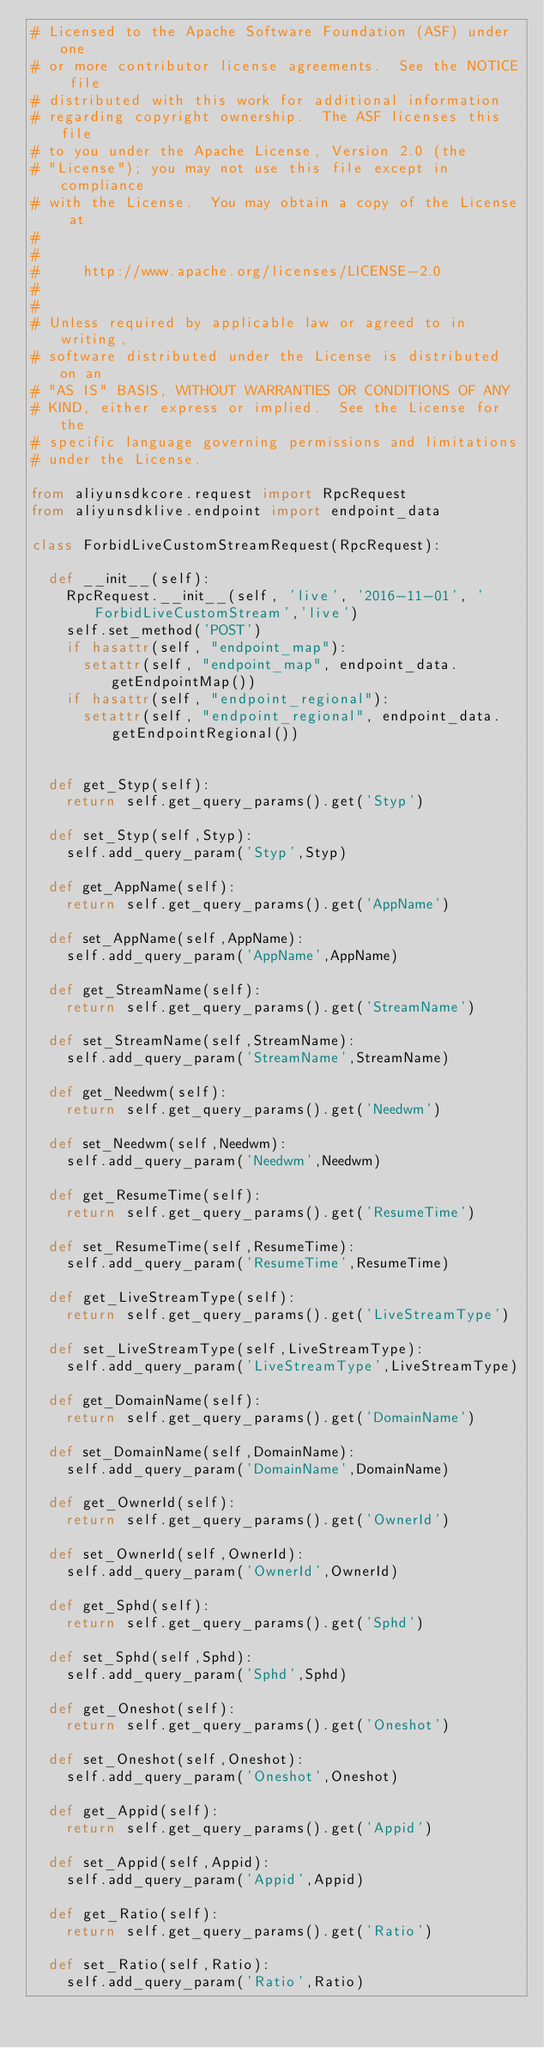<code> <loc_0><loc_0><loc_500><loc_500><_Python_># Licensed to the Apache Software Foundation (ASF) under one
# or more contributor license agreements.  See the NOTICE file
# distributed with this work for additional information
# regarding copyright ownership.  The ASF licenses this file
# to you under the Apache License, Version 2.0 (the
# "License"); you may not use this file except in compliance
# with the License.  You may obtain a copy of the License at
#
#
#     http://www.apache.org/licenses/LICENSE-2.0
#
#
# Unless required by applicable law or agreed to in writing,
# software distributed under the License is distributed on an
# "AS IS" BASIS, WITHOUT WARRANTIES OR CONDITIONS OF ANY
# KIND, either express or implied.  See the License for the
# specific language governing permissions and limitations
# under the License.

from aliyunsdkcore.request import RpcRequest
from aliyunsdklive.endpoint import endpoint_data

class ForbidLiveCustomStreamRequest(RpcRequest):

	def __init__(self):
		RpcRequest.__init__(self, 'live', '2016-11-01', 'ForbidLiveCustomStream','live')
		self.set_method('POST')
		if hasattr(self, "endpoint_map"):
			setattr(self, "endpoint_map", endpoint_data.getEndpointMap())
		if hasattr(self, "endpoint_regional"):
			setattr(self, "endpoint_regional", endpoint_data.getEndpointRegional())


	def get_Styp(self):
		return self.get_query_params().get('Styp')

	def set_Styp(self,Styp):
		self.add_query_param('Styp',Styp)

	def get_AppName(self):
		return self.get_query_params().get('AppName')

	def set_AppName(self,AppName):
		self.add_query_param('AppName',AppName)

	def get_StreamName(self):
		return self.get_query_params().get('StreamName')

	def set_StreamName(self,StreamName):
		self.add_query_param('StreamName',StreamName)

	def get_Needwm(self):
		return self.get_query_params().get('Needwm')

	def set_Needwm(self,Needwm):
		self.add_query_param('Needwm',Needwm)

	def get_ResumeTime(self):
		return self.get_query_params().get('ResumeTime')

	def set_ResumeTime(self,ResumeTime):
		self.add_query_param('ResumeTime',ResumeTime)

	def get_LiveStreamType(self):
		return self.get_query_params().get('LiveStreamType')

	def set_LiveStreamType(self,LiveStreamType):
		self.add_query_param('LiveStreamType',LiveStreamType)

	def get_DomainName(self):
		return self.get_query_params().get('DomainName')

	def set_DomainName(self,DomainName):
		self.add_query_param('DomainName',DomainName)

	def get_OwnerId(self):
		return self.get_query_params().get('OwnerId')

	def set_OwnerId(self,OwnerId):
		self.add_query_param('OwnerId',OwnerId)

	def get_Sphd(self):
		return self.get_query_params().get('Sphd')

	def set_Sphd(self,Sphd):
		self.add_query_param('Sphd',Sphd)

	def get_Oneshot(self):
		return self.get_query_params().get('Oneshot')

	def set_Oneshot(self,Oneshot):
		self.add_query_param('Oneshot',Oneshot)

	def get_Appid(self):
		return self.get_query_params().get('Appid')

	def set_Appid(self,Appid):
		self.add_query_param('Appid',Appid)

	def get_Ratio(self):
		return self.get_query_params().get('Ratio')

	def set_Ratio(self,Ratio):
		self.add_query_param('Ratio',Ratio)</code> 